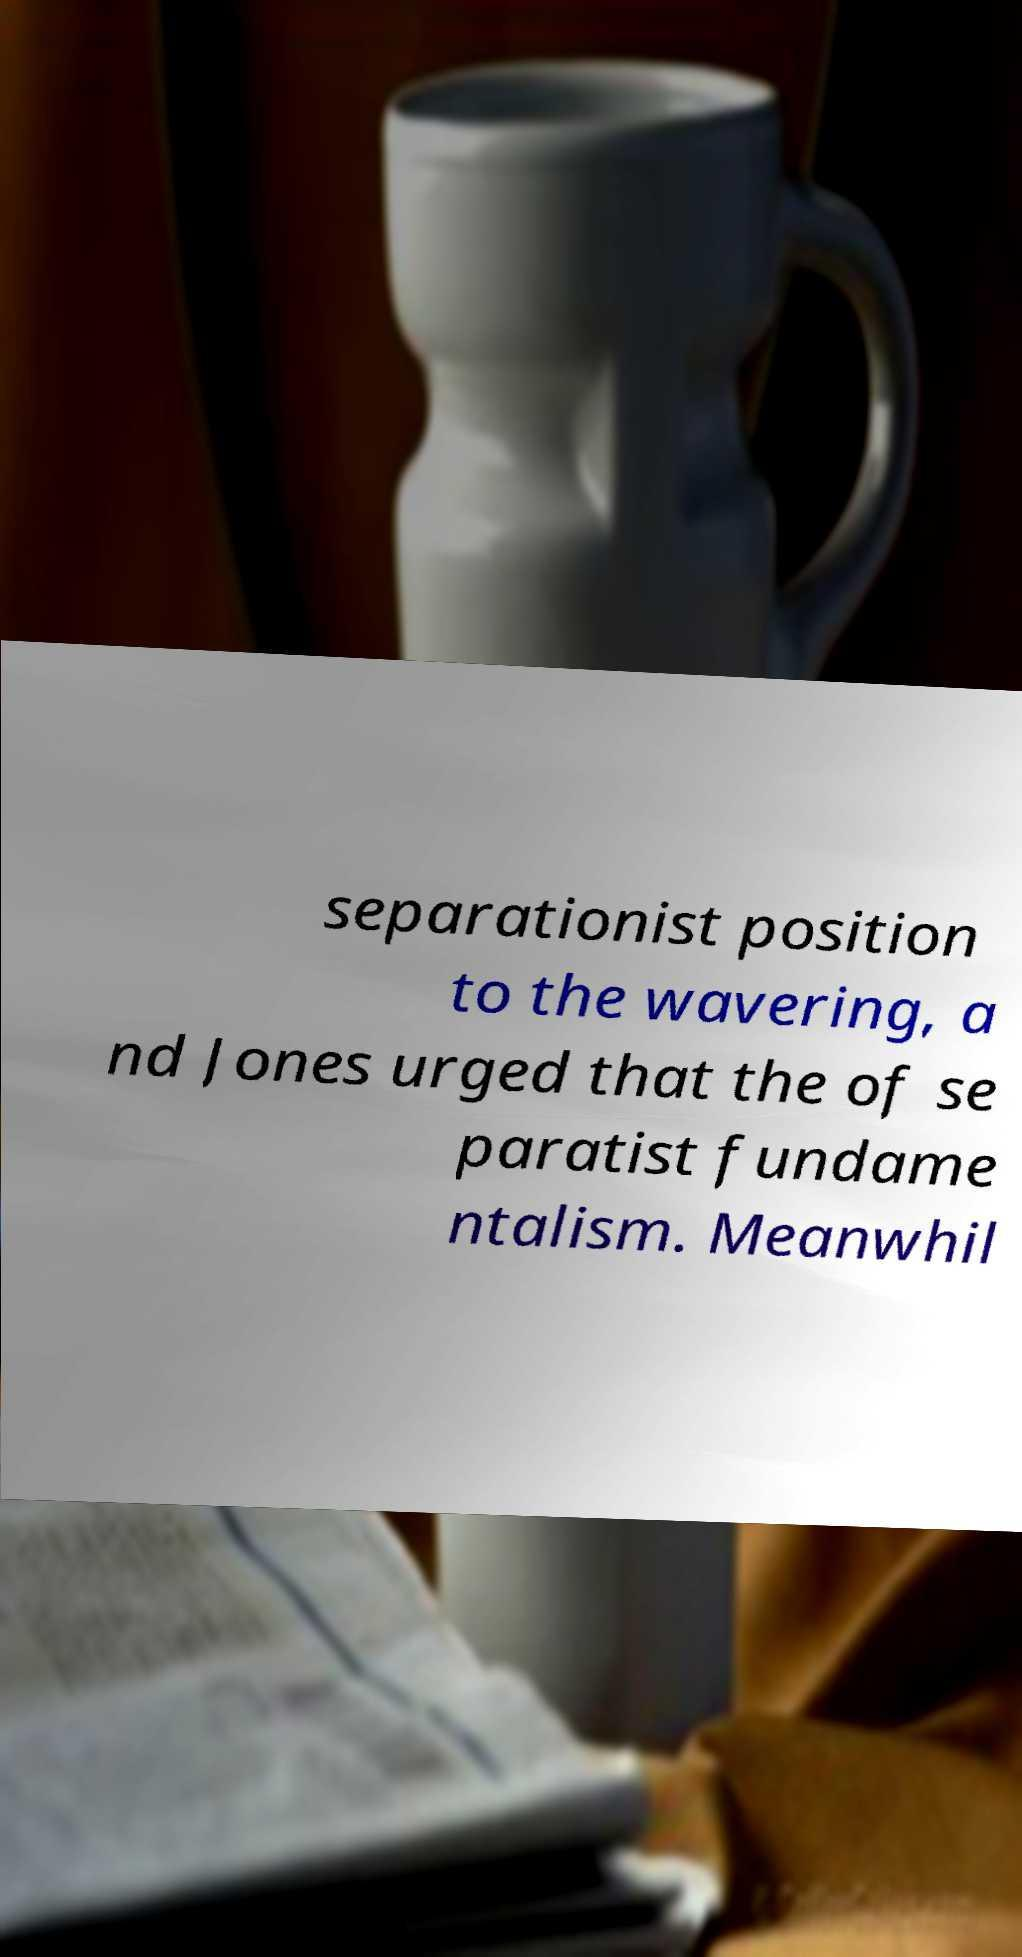Can you read and provide the text displayed in the image?This photo seems to have some interesting text. Can you extract and type it out for me? separationist position to the wavering, a nd Jones urged that the of se paratist fundame ntalism. Meanwhil 